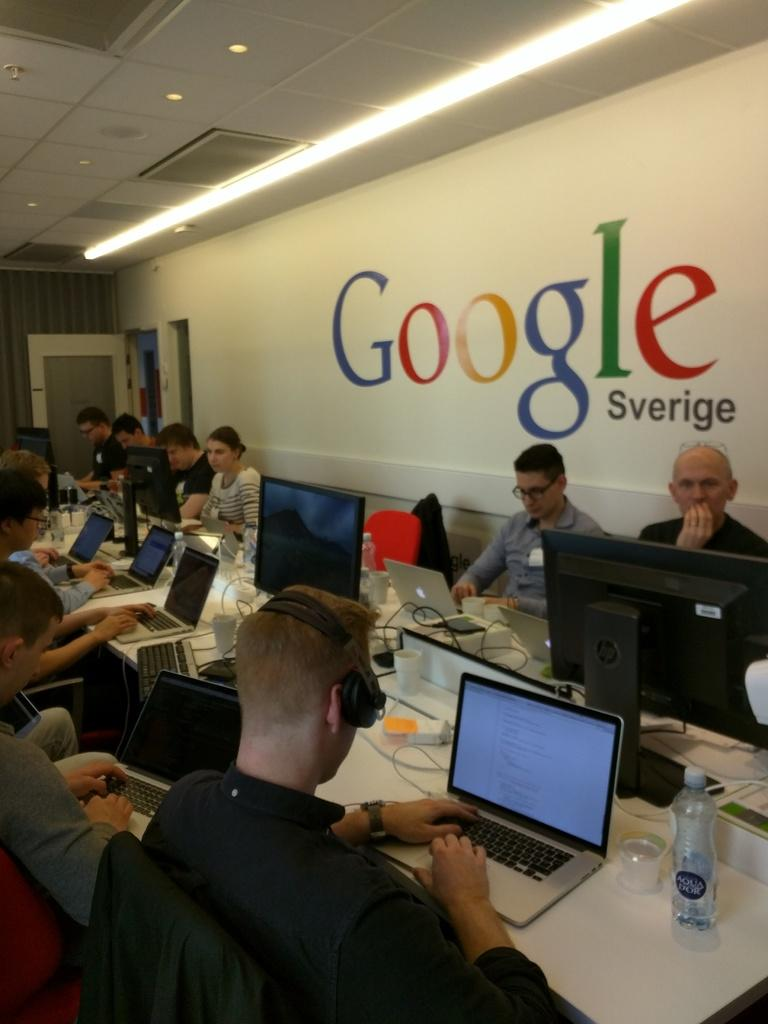What type of structure can be seen in the image? There is a wall in the image. What can be used for illumination in the image? There is a light in the image. How can someone enter or exit the room in the image? There is a door in the image. What are the people in the image doing? There are people sitting on chairs in the image. What is on the table in the image? There is a table in the image with laptops, bottles, wires, and glasses on it. What type of stem is growing out of the laptop in the image? There is no stem growing out of the laptop in the image; it is a laptop with no plant life present. What advice does the son give to his father in the image? There is no son or father present in the image, and therefore no such conversation can be observed. 